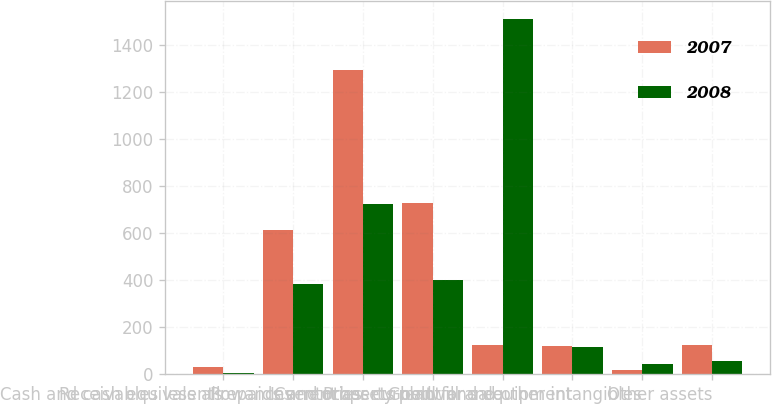Convert chart. <chart><loc_0><loc_0><loc_500><loc_500><stacked_bar_chart><ecel><fcel>Cash and cash equivalents<fcel>Receivables less allowances<fcel>Inventories<fcel>Prepaids and other current<fcel>Current assets held for sale<fcel>Property plant and equipment<fcel>Goodwill and other intangibles<fcel>Other assets<nl><fcel>2007<fcel>30.8<fcel>614.9<fcel>1294.2<fcel>727.5<fcel>121.5<fcel>119<fcel>17<fcel>121.5<nl><fcel>2008<fcel>4.4<fcel>384.1<fcel>723.4<fcel>400<fcel>1511.9<fcel>114.7<fcel>43.3<fcel>54.6<nl></chart> 